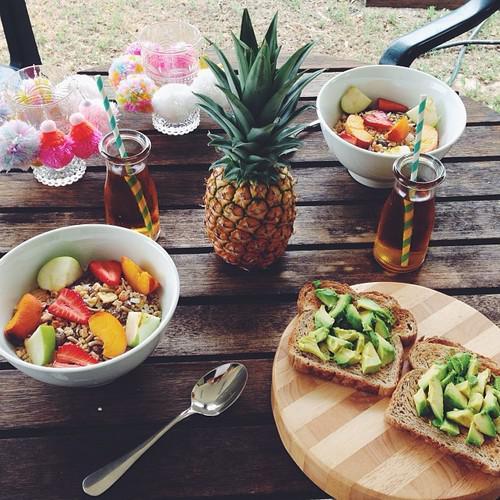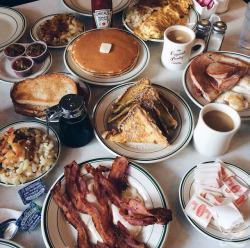The first image is the image on the left, the second image is the image on the right. Considering the images on both sides, is "The right image shows only breakfast pizza." valid? Answer yes or no. No. The first image is the image on the left, the second image is the image on the right. Analyze the images presented: Is the assertion "A whole pizza is on the table." valid? Answer yes or no. No. 